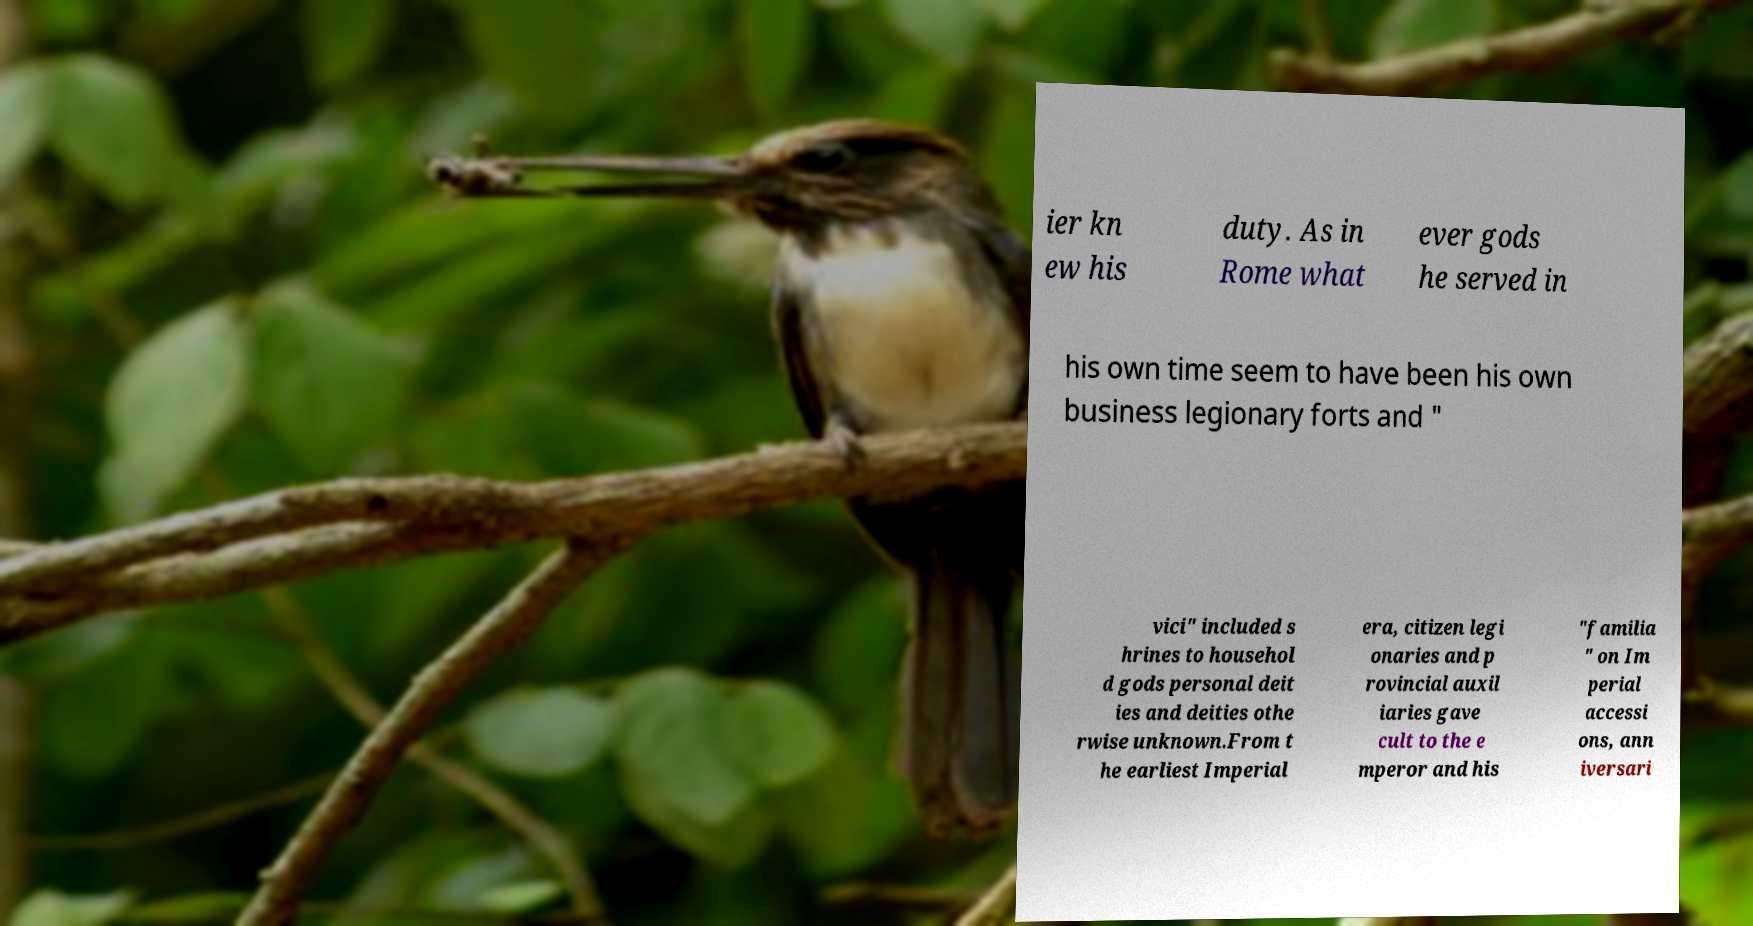There's text embedded in this image that I need extracted. Can you transcribe it verbatim? ier kn ew his duty. As in Rome what ever gods he served in his own time seem to have been his own business legionary forts and " vici" included s hrines to househol d gods personal deit ies and deities othe rwise unknown.From t he earliest Imperial era, citizen legi onaries and p rovincial auxil iaries gave cult to the e mperor and his "familia " on Im perial accessi ons, ann iversari 